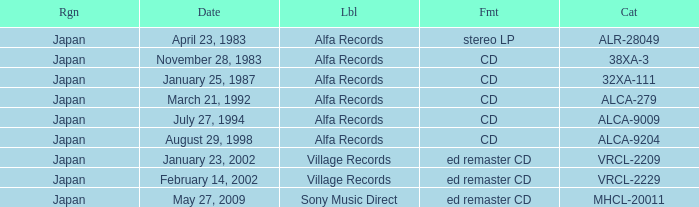Which label is dated February 14, 2002? Village Records. 